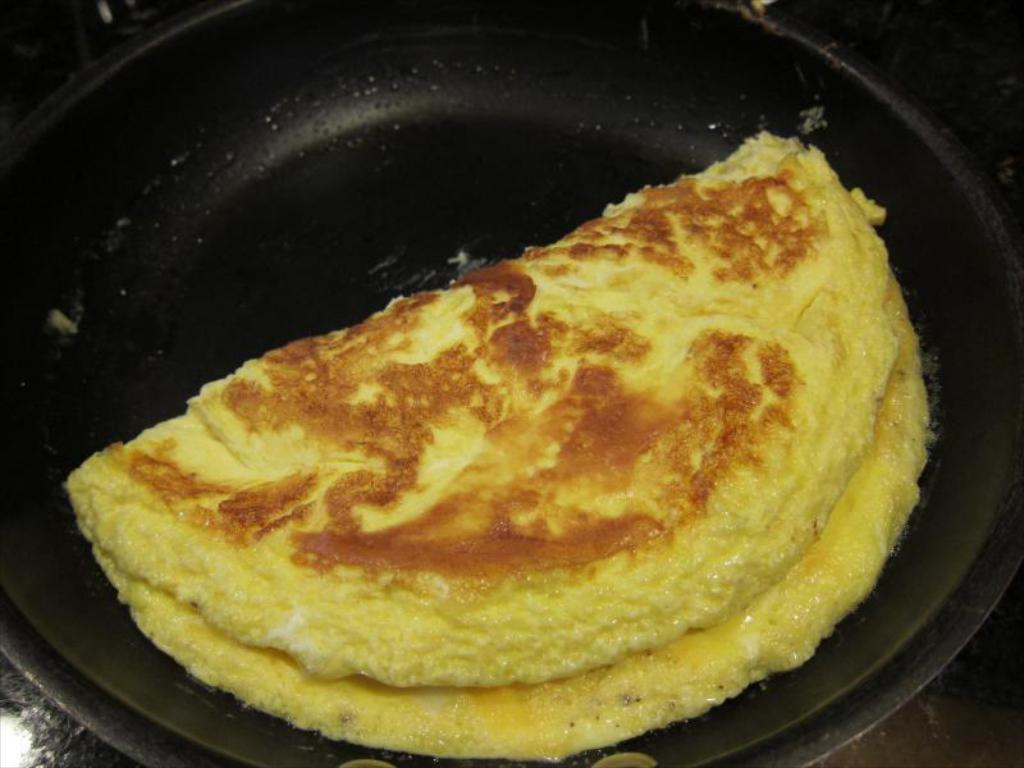What is the main object in the image? There is a pan in the image. What is inside the pan? The pan contains an egg omelette. What type of pleasure can be seen enjoying the pet cakes in the image? There is no indication of pleasure, pets, or cakes in the image; it only features a pan with an egg omelette. 